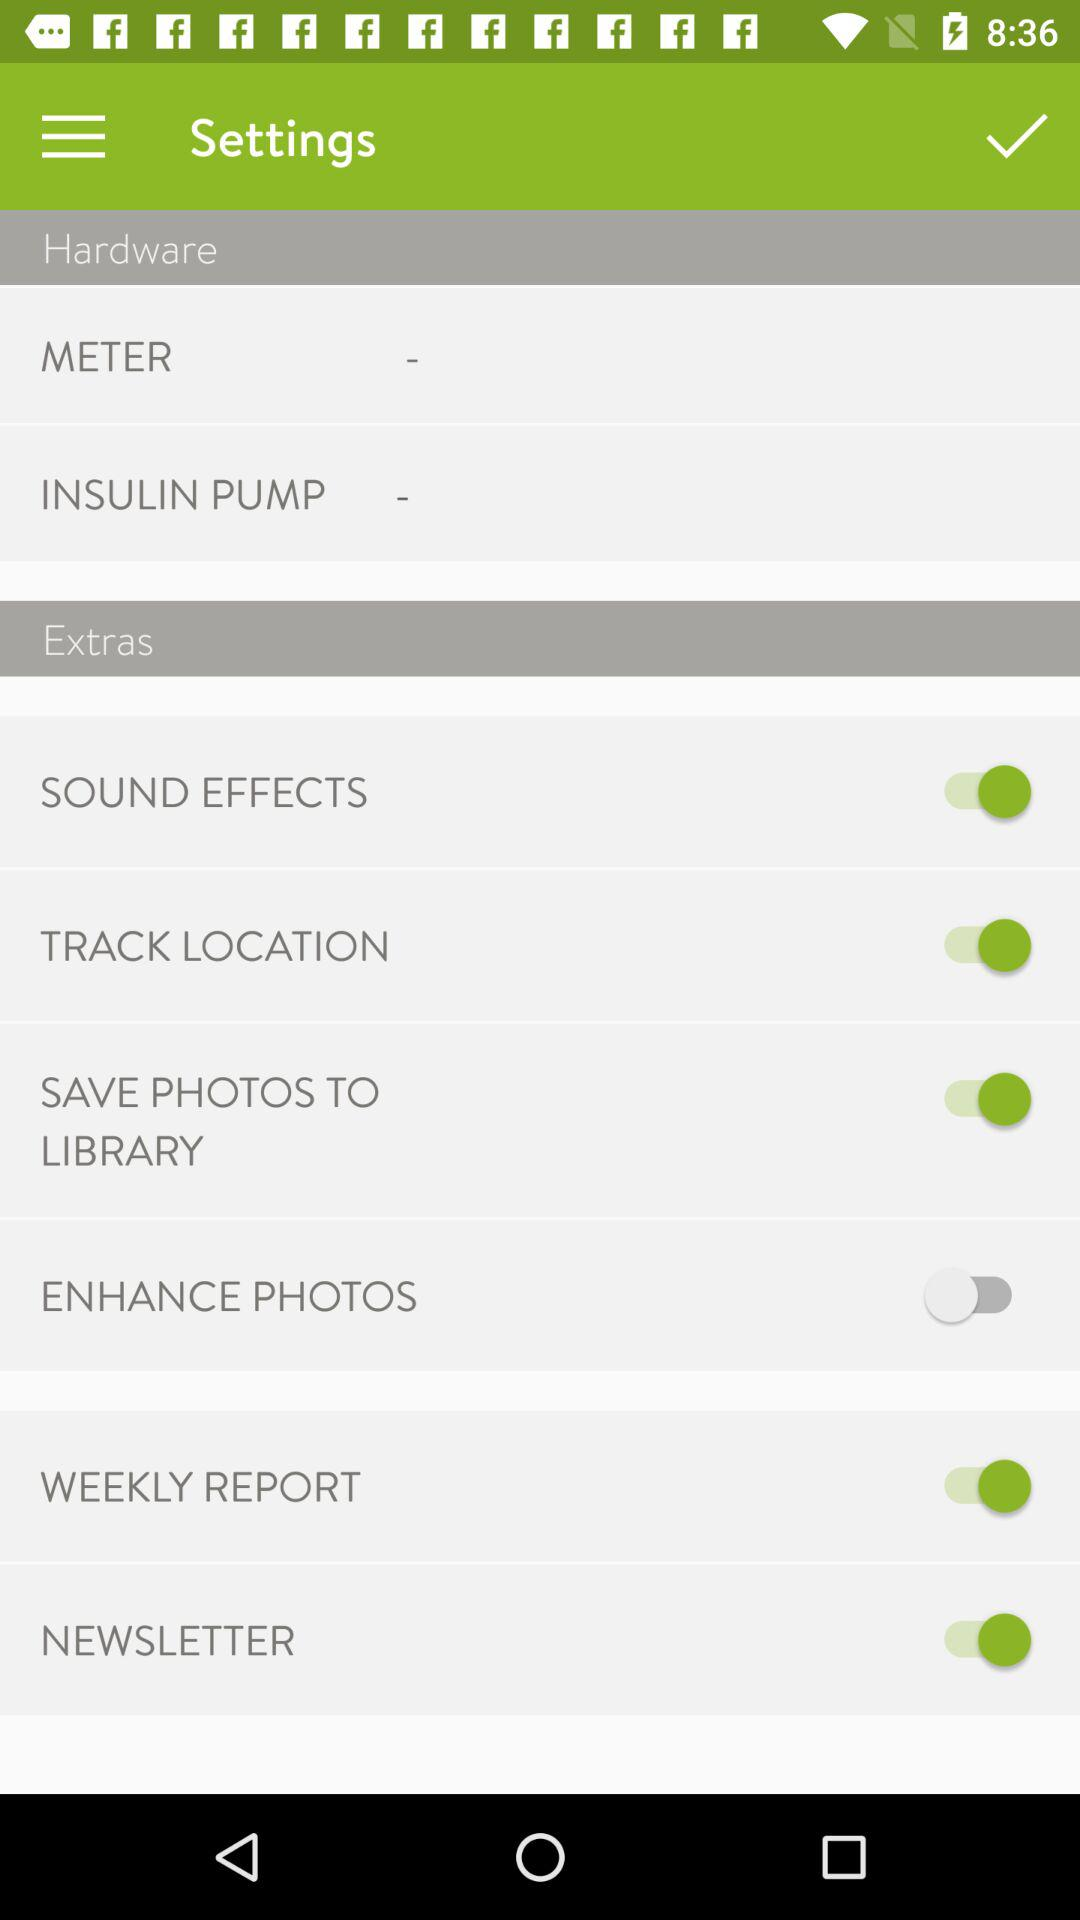What is the status of "ENHANCE PHOTOS"? The status of "ENHANCE PHOTOS" is "off". 